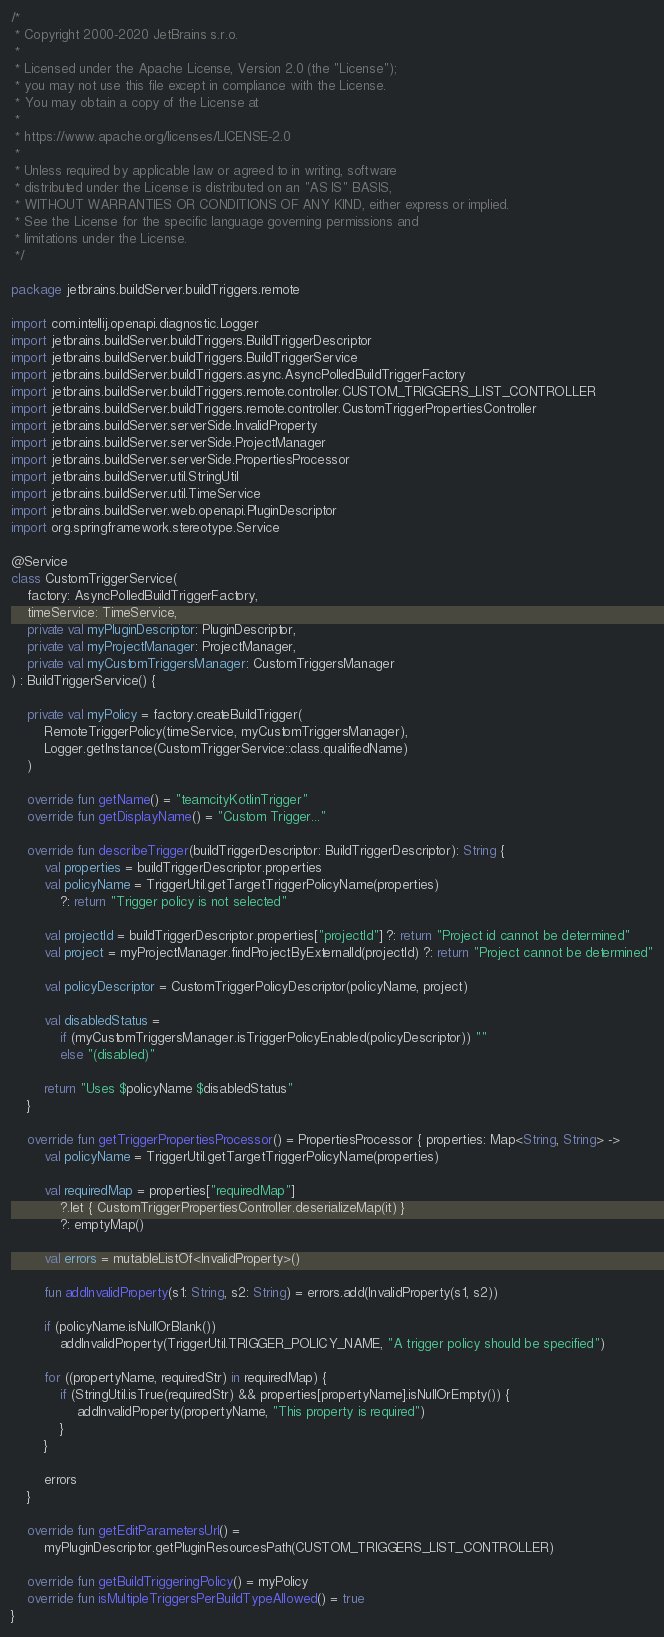Convert code to text. <code><loc_0><loc_0><loc_500><loc_500><_Kotlin_>/*
 * Copyright 2000-2020 JetBrains s.r.o.
 *
 * Licensed under the Apache License, Version 2.0 (the "License");
 * you may not use this file except in compliance with the License.
 * You may obtain a copy of the License at
 *
 * https://www.apache.org/licenses/LICENSE-2.0
 *
 * Unless required by applicable law or agreed to in writing, software
 * distributed under the License is distributed on an "AS IS" BASIS,
 * WITHOUT WARRANTIES OR CONDITIONS OF ANY KIND, either express or implied.
 * See the License for the specific language governing permissions and
 * limitations under the License.
 */

package jetbrains.buildServer.buildTriggers.remote

import com.intellij.openapi.diagnostic.Logger
import jetbrains.buildServer.buildTriggers.BuildTriggerDescriptor
import jetbrains.buildServer.buildTriggers.BuildTriggerService
import jetbrains.buildServer.buildTriggers.async.AsyncPolledBuildTriggerFactory
import jetbrains.buildServer.buildTriggers.remote.controller.CUSTOM_TRIGGERS_LIST_CONTROLLER
import jetbrains.buildServer.buildTriggers.remote.controller.CustomTriggerPropertiesController
import jetbrains.buildServer.serverSide.InvalidProperty
import jetbrains.buildServer.serverSide.ProjectManager
import jetbrains.buildServer.serverSide.PropertiesProcessor
import jetbrains.buildServer.util.StringUtil
import jetbrains.buildServer.util.TimeService
import jetbrains.buildServer.web.openapi.PluginDescriptor
import org.springframework.stereotype.Service

@Service
class CustomTriggerService(
    factory: AsyncPolledBuildTriggerFactory,
    timeService: TimeService,
    private val myPluginDescriptor: PluginDescriptor,
    private val myProjectManager: ProjectManager,
    private val myCustomTriggersManager: CustomTriggersManager
) : BuildTriggerService() {

    private val myPolicy = factory.createBuildTrigger(
        RemoteTriggerPolicy(timeService, myCustomTriggersManager),
        Logger.getInstance(CustomTriggerService::class.qualifiedName)
    )

    override fun getName() = "teamcityKotlinTrigger"
    override fun getDisplayName() = "Custom Trigger..."

    override fun describeTrigger(buildTriggerDescriptor: BuildTriggerDescriptor): String {
        val properties = buildTriggerDescriptor.properties
        val policyName = TriggerUtil.getTargetTriggerPolicyName(properties)
            ?: return "Trigger policy is not selected"

        val projectId = buildTriggerDescriptor.properties["projectId"] ?: return "Project id cannot be determined"
        val project = myProjectManager.findProjectByExternalId(projectId) ?: return "Project cannot be determined"

        val policyDescriptor = CustomTriggerPolicyDescriptor(policyName, project)

        val disabledStatus =
            if (myCustomTriggersManager.isTriggerPolicyEnabled(policyDescriptor)) ""
            else "(disabled)"

        return "Uses $policyName $disabledStatus"
    }

    override fun getTriggerPropertiesProcessor() = PropertiesProcessor { properties: Map<String, String> ->
        val policyName = TriggerUtil.getTargetTriggerPolicyName(properties)

        val requiredMap = properties["requiredMap"]
            ?.let { CustomTriggerPropertiesController.deserializeMap(it) }
            ?: emptyMap()

        val errors = mutableListOf<InvalidProperty>()

        fun addInvalidProperty(s1: String, s2: String) = errors.add(InvalidProperty(s1, s2))

        if (policyName.isNullOrBlank())
            addInvalidProperty(TriggerUtil.TRIGGER_POLICY_NAME, "A trigger policy should be specified")

        for ((propertyName, requiredStr) in requiredMap) {
            if (StringUtil.isTrue(requiredStr) && properties[propertyName].isNullOrEmpty()) {
                addInvalidProperty(propertyName, "This property is required")
            }
        }

        errors
    }

    override fun getEditParametersUrl() =
        myPluginDescriptor.getPluginResourcesPath(CUSTOM_TRIGGERS_LIST_CONTROLLER)

    override fun getBuildTriggeringPolicy() = myPolicy
    override fun isMultipleTriggersPerBuildTypeAllowed() = true
}
</code> 